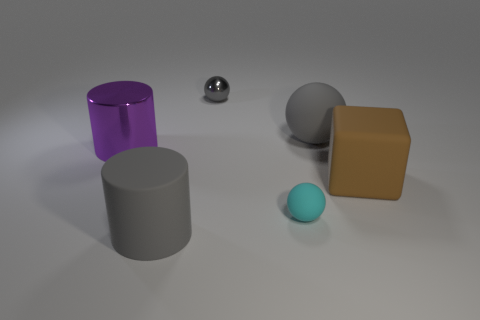Add 2 big brown objects. How many objects exist? 8 Subtract all cylinders. How many objects are left? 4 Subtract 0 blue cubes. How many objects are left? 6 Subtract all tiny gray metallic balls. Subtract all big purple metal things. How many objects are left? 4 Add 4 small gray objects. How many small gray objects are left? 5 Add 2 balls. How many balls exist? 5 